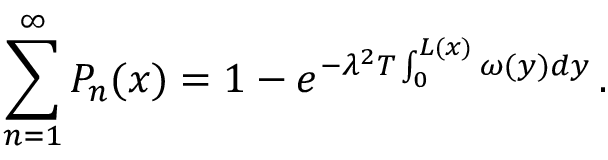<formula> <loc_0><loc_0><loc_500><loc_500>\sum _ { n = 1 } ^ { \infty } P _ { n } ( x ) = 1 - e ^ { - \lambda ^ { 2 } T \int _ { 0 } ^ { L ( x ) } \omega ( y ) d y } \, .</formula> 